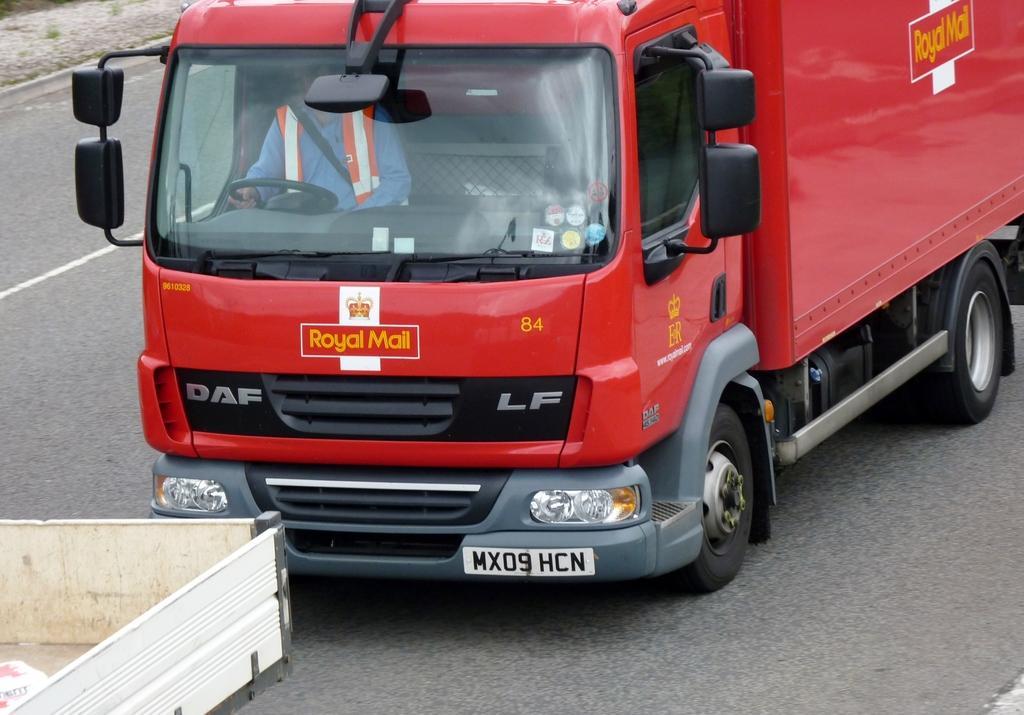Could you give a brief overview of what you see in this image? In this picture we can see vehicles on the road, there is a man inside a vehicle. We can see number plate on this vehicle. 